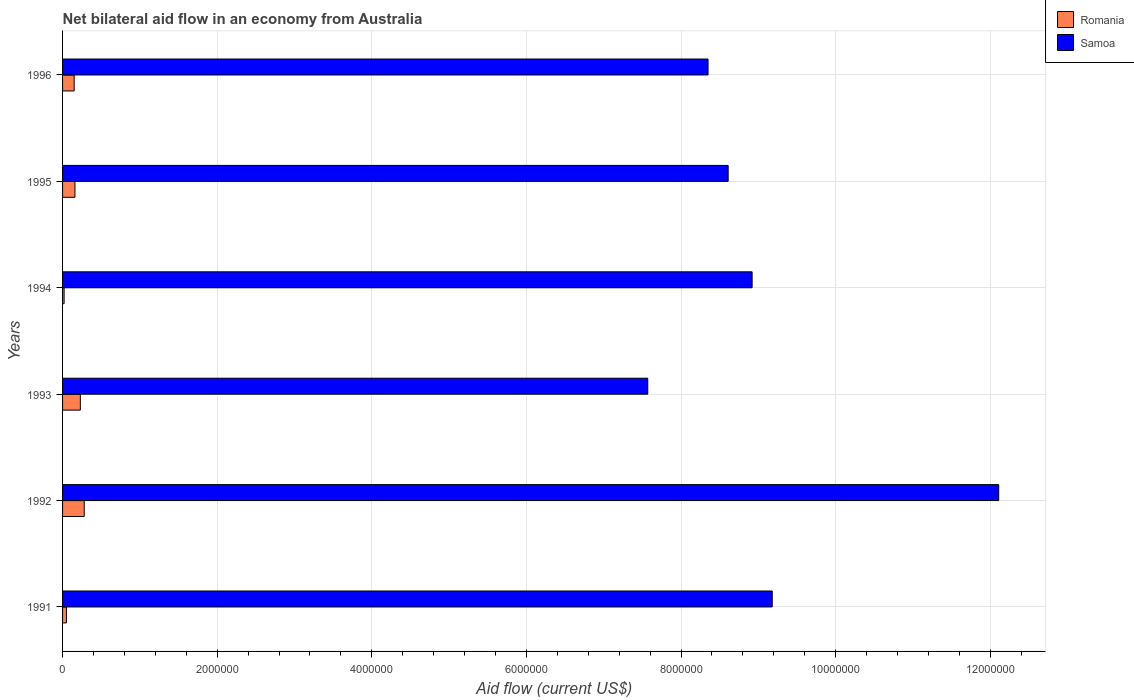How many different coloured bars are there?
Your response must be concise. 2. Are the number of bars per tick equal to the number of legend labels?
Your answer should be compact. Yes. Are the number of bars on each tick of the Y-axis equal?
Provide a succinct answer. Yes. How many bars are there on the 3rd tick from the top?
Your answer should be very brief. 2. Across all years, what is the maximum net bilateral aid flow in Romania?
Offer a terse response. 2.80e+05. In which year was the net bilateral aid flow in Samoa maximum?
Offer a terse response. 1992. In which year was the net bilateral aid flow in Romania minimum?
Offer a very short reply. 1994. What is the total net bilateral aid flow in Romania in the graph?
Offer a terse response. 8.90e+05. What is the difference between the net bilateral aid flow in Romania in 1993 and that in 1996?
Offer a terse response. 8.00e+04. What is the difference between the net bilateral aid flow in Samoa in 1996 and the net bilateral aid flow in Romania in 1995?
Ensure brevity in your answer.  8.19e+06. What is the average net bilateral aid flow in Samoa per year?
Offer a terse response. 9.12e+06. In the year 1991, what is the difference between the net bilateral aid flow in Samoa and net bilateral aid flow in Romania?
Offer a terse response. 9.13e+06. In how many years, is the net bilateral aid flow in Samoa greater than 3600000 US$?
Your answer should be very brief. 6. What is the ratio of the net bilateral aid flow in Romania in 1991 to that in 1996?
Provide a succinct answer. 0.33. Is the net bilateral aid flow in Samoa in 1993 less than that in 1996?
Your response must be concise. Yes. What is the difference between the highest and the second highest net bilateral aid flow in Samoa?
Offer a terse response. 2.93e+06. In how many years, is the net bilateral aid flow in Romania greater than the average net bilateral aid flow in Romania taken over all years?
Your response must be concise. 4. What does the 1st bar from the top in 1991 represents?
Your answer should be very brief. Samoa. What does the 1st bar from the bottom in 1996 represents?
Make the answer very short. Romania. Are all the bars in the graph horizontal?
Your answer should be compact. Yes. How many years are there in the graph?
Offer a terse response. 6. What is the difference between two consecutive major ticks on the X-axis?
Make the answer very short. 2.00e+06. Are the values on the major ticks of X-axis written in scientific E-notation?
Your answer should be very brief. No. Does the graph contain any zero values?
Ensure brevity in your answer.  No. Does the graph contain grids?
Your answer should be compact. Yes. What is the title of the graph?
Offer a terse response. Net bilateral aid flow in an economy from Australia. Does "Heavily indebted poor countries" appear as one of the legend labels in the graph?
Offer a very short reply. No. What is the label or title of the X-axis?
Offer a terse response. Aid flow (current US$). What is the Aid flow (current US$) of Romania in 1991?
Your answer should be compact. 5.00e+04. What is the Aid flow (current US$) of Samoa in 1991?
Provide a succinct answer. 9.18e+06. What is the Aid flow (current US$) in Samoa in 1992?
Make the answer very short. 1.21e+07. What is the Aid flow (current US$) in Samoa in 1993?
Ensure brevity in your answer.  7.57e+06. What is the Aid flow (current US$) of Romania in 1994?
Ensure brevity in your answer.  2.00e+04. What is the Aid flow (current US$) in Samoa in 1994?
Offer a terse response. 8.92e+06. What is the Aid flow (current US$) of Samoa in 1995?
Ensure brevity in your answer.  8.61e+06. What is the Aid flow (current US$) of Samoa in 1996?
Keep it short and to the point. 8.35e+06. Across all years, what is the maximum Aid flow (current US$) in Samoa?
Your answer should be compact. 1.21e+07. Across all years, what is the minimum Aid flow (current US$) in Samoa?
Offer a very short reply. 7.57e+06. What is the total Aid flow (current US$) of Romania in the graph?
Provide a short and direct response. 8.90e+05. What is the total Aid flow (current US$) in Samoa in the graph?
Your answer should be compact. 5.47e+07. What is the difference between the Aid flow (current US$) in Samoa in 1991 and that in 1992?
Make the answer very short. -2.93e+06. What is the difference between the Aid flow (current US$) of Samoa in 1991 and that in 1993?
Your answer should be very brief. 1.61e+06. What is the difference between the Aid flow (current US$) of Romania in 1991 and that in 1995?
Give a very brief answer. -1.10e+05. What is the difference between the Aid flow (current US$) in Samoa in 1991 and that in 1995?
Your answer should be compact. 5.70e+05. What is the difference between the Aid flow (current US$) in Samoa in 1991 and that in 1996?
Ensure brevity in your answer.  8.30e+05. What is the difference between the Aid flow (current US$) in Romania in 1992 and that in 1993?
Give a very brief answer. 5.00e+04. What is the difference between the Aid flow (current US$) in Samoa in 1992 and that in 1993?
Provide a succinct answer. 4.54e+06. What is the difference between the Aid flow (current US$) in Samoa in 1992 and that in 1994?
Your answer should be compact. 3.19e+06. What is the difference between the Aid flow (current US$) in Romania in 1992 and that in 1995?
Ensure brevity in your answer.  1.20e+05. What is the difference between the Aid flow (current US$) in Samoa in 1992 and that in 1995?
Your response must be concise. 3.50e+06. What is the difference between the Aid flow (current US$) in Samoa in 1992 and that in 1996?
Keep it short and to the point. 3.76e+06. What is the difference between the Aid flow (current US$) in Romania in 1993 and that in 1994?
Your answer should be compact. 2.10e+05. What is the difference between the Aid flow (current US$) in Samoa in 1993 and that in 1994?
Keep it short and to the point. -1.35e+06. What is the difference between the Aid flow (current US$) in Romania in 1993 and that in 1995?
Your response must be concise. 7.00e+04. What is the difference between the Aid flow (current US$) of Samoa in 1993 and that in 1995?
Give a very brief answer. -1.04e+06. What is the difference between the Aid flow (current US$) of Samoa in 1993 and that in 1996?
Make the answer very short. -7.80e+05. What is the difference between the Aid flow (current US$) of Romania in 1994 and that in 1995?
Offer a very short reply. -1.40e+05. What is the difference between the Aid flow (current US$) of Samoa in 1994 and that in 1995?
Offer a terse response. 3.10e+05. What is the difference between the Aid flow (current US$) in Romania in 1994 and that in 1996?
Provide a succinct answer. -1.30e+05. What is the difference between the Aid flow (current US$) of Samoa in 1994 and that in 1996?
Provide a short and direct response. 5.70e+05. What is the difference between the Aid flow (current US$) of Romania in 1991 and the Aid flow (current US$) of Samoa in 1992?
Your answer should be very brief. -1.21e+07. What is the difference between the Aid flow (current US$) of Romania in 1991 and the Aid flow (current US$) of Samoa in 1993?
Offer a very short reply. -7.52e+06. What is the difference between the Aid flow (current US$) in Romania in 1991 and the Aid flow (current US$) in Samoa in 1994?
Your answer should be very brief. -8.87e+06. What is the difference between the Aid flow (current US$) in Romania in 1991 and the Aid flow (current US$) in Samoa in 1995?
Offer a very short reply. -8.56e+06. What is the difference between the Aid flow (current US$) in Romania in 1991 and the Aid flow (current US$) in Samoa in 1996?
Your answer should be very brief. -8.30e+06. What is the difference between the Aid flow (current US$) in Romania in 1992 and the Aid flow (current US$) in Samoa in 1993?
Your answer should be compact. -7.29e+06. What is the difference between the Aid flow (current US$) in Romania in 1992 and the Aid flow (current US$) in Samoa in 1994?
Offer a very short reply. -8.64e+06. What is the difference between the Aid flow (current US$) in Romania in 1992 and the Aid flow (current US$) in Samoa in 1995?
Your response must be concise. -8.33e+06. What is the difference between the Aid flow (current US$) of Romania in 1992 and the Aid flow (current US$) of Samoa in 1996?
Offer a very short reply. -8.07e+06. What is the difference between the Aid flow (current US$) of Romania in 1993 and the Aid flow (current US$) of Samoa in 1994?
Provide a short and direct response. -8.69e+06. What is the difference between the Aid flow (current US$) of Romania in 1993 and the Aid flow (current US$) of Samoa in 1995?
Offer a terse response. -8.38e+06. What is the difference between the Aid flow (current US$) in Romania in 1993 and the Aid flow (current US$) in Samoa in 1996?
Keep it short and to the point. -8.12e+06. What is the difference between the Aid flow (current US$) of Romania in 1994 and the Aid flow (current US$) of Samoa in 1995?
Your answer should be very brief. -8.59e+06. What is the difference between the Aid flow (current US$) in Romania in 1994 and the Aid flow (current US$) in Samoa in 1996?
Give a very brief answer. -8.33e+06. What is the difference between the Aid flow (current US$) in Romania in 1995 and the Aid flow (current US$) in Samoa in 1996?
Your response must be concise. -8.19e+06. What is the average Aid flow (current US$) of Romania per year?
Offer a very short reply. 1.48e+05. What is the average Aid flow (current US$) of Samoa per year?
Offer a very short reply. 9.12e+06. In the year 1991, what is the difference between the Aid flow (current US$) of Romania and Aid flow (current US$) of Samoa?
Keep it short and to the point. -9.13e+06. In the year 1992, what is the difference between the Aid flow (current US$) in Romania and Aid flow (current US$) in Samoa?
Give a very brief answer. -1.18e+07. In the year 1993, what is the difference between the Aid flow (current US$) in Romania and Aid flow (current US$) in Samoa?
Your answer should be very brief. -7.34e+06. In the year 1994, what is the difference between the Aid flow (current US$) of Romania and Aid flow (current US$) of Samoa?
Keep it short and to the point. -8.90e+06. In the year 1995, what is the difference between the Aid flow (current US$) in Romania and Aid flow (current US$) in Samoa?
Your response must be concise. -8.45e+06. In the year 1996, what is the difference between the Aid flow (current US$) of Romania and Aid flow (current US$) of Samoa?
Provide a succinct answer. -8.20e+06. What is the ratio of the Aid flow (current US$) of Romania in 1991 to that in 1992?
Ensure brevity in your answer.  0.18. What is the ratio of the Aid flow (current US$) of Samoa in 1991 to that in 1992?
Your response must be concise. 0.76. What is the ratio of the Aid flow (current US$) in Romania in 1991 to that in 1993?
Make the answer very short. 0.22. What is the ratio of the Aid flow (current US$) in Samoa in 1991 to that in 1993?
Keep it short and to the point. 1.21. What is the ratio of the Aid flow (current US$) in Romania in 1991 to that in 1994?
Give a very brief answer. 2.5. What is the ratio of the Aid flow (current US$) of Samoa in 1991 to that in 1994?
Your response must be concise. 1.03. What is the ratio of the Aid flow (current US$) of Romania in 1991 to that in 1995?
Provide a short and direct response. 0.31. What is the ratio of the Aid flow (current US$) in Samoa in 1991 to that in 1995?
Keep it short and to the point. 1.07. What is the ratio of the Aid flow (current US$) of Samoa in 1991 to that in 1996?
Your answer should be compact. 1.1. What is the ratio of the Aid flow (current US$) of Romania in 1992 to that in 1993?
Make the answer very short. 1.22. What is the ratio of the Aid flow (current US$) in Samoa in 1992 to that in 1993?
Give a very brief answer. 1.6. What is the ratio of the Aid flow (current US$) in Romania in 1992 to that in 1994?
Provide a short and direct response. 14. What is the ratio of the Aid flow (current US$) in Samoa in 1992 to that in 1994?
Your response must be concise. 1.36. What is the ratio of the Aid flow (current US$) of Romania in 1992 to that in 1995?
Ensure brevity in your answer.  1.75. What is the ratio of the Aid flow (current US$) in Samoa in 1992 to that in 1995?
Your response must be concise. 1.41. What is the ratio of the Aid flow (current US$) of Romania in 1992 to that in 1996?
Your answer should be compact. 1.87. What is the ratio of the Aid flow (current US$) of Samoa in 1992 to that in 1996?
Give a very brief answer. 1.45. What is the ratio of the Aid flow (current US$) of Samoa in 1993 to that in 1994?
Give a very brief answer. 0.85. What is the ratio of the Aid flow (current US$) of Romania in 1993 to that in 1995?
Ensure brevity in your answer.  1.44. What is the ratio of the Aid flow (current US$) in Samoa in 1993 to that in 1995?
Ensure brevity in your answer.  0.88. What is the ratio of the Aid flow (current US$) of Romania in 1993 to that in 1996?
Make the answer very short. 1.53. What is the ratio of the Aid flow (current US$) in Samoa in 1993 to that in 1996?
Your answer should be very brief. 0.91. What is the ratio of the Aid flow (current US$) in Samoa in 1994 to that in 1995?
Ensure brevity in your answer.  1.04. What is the ratio of the Aid flow (current US$) in Romania in 1994 to that in 1996?
Your response must be concise. 0.13. What is the ratio of the Aid flow (current US$) in Samoa in 1994 to that in 1996?
Keep it short and to the point. 1.07. What is the ratio of the Aid flow (current US$) in Romania in 1995 to that in 1996?
Your response must be concise. 1.07. What is the ratio of the Aid flow (current US$) in Samoa in 1995 to that in 1996?
Provide a short and direct response. 1.03. What is the difference between the highest and the second highest Aid flow (current US$) in Romania?
Offer a terse response. 5.00e+04. What is the difference between the highest and the second highest Aid flow (current US$) of Samoa?
Keep it short and to the point. 2.93e+06. What is the difference between the highest and the lowest Aid flow (current US$) in Samoa?
Keep it short and to the point. 4.54e+06. 